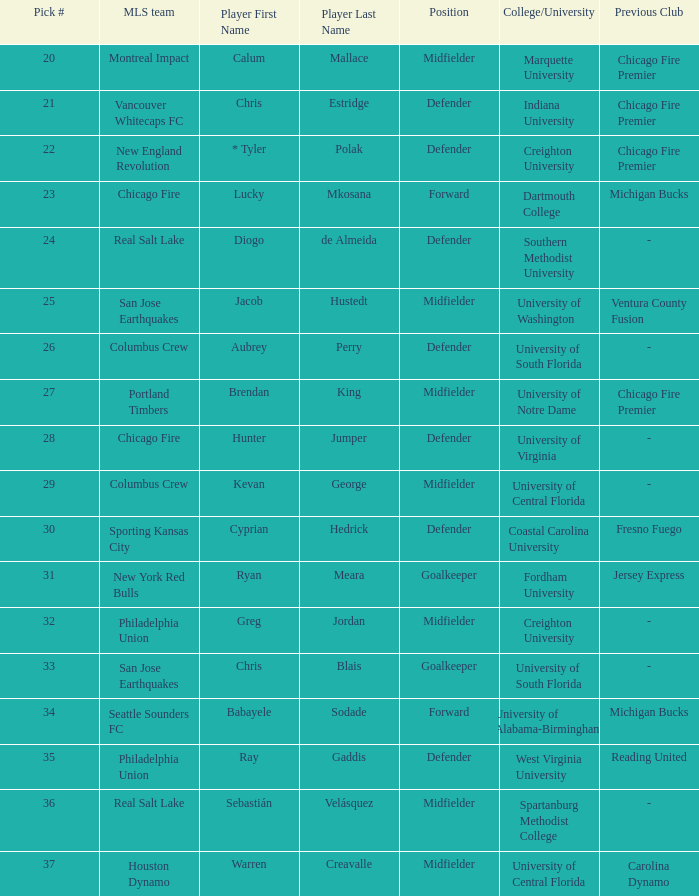What pick number did Real Salt Lake get? 24.0. 